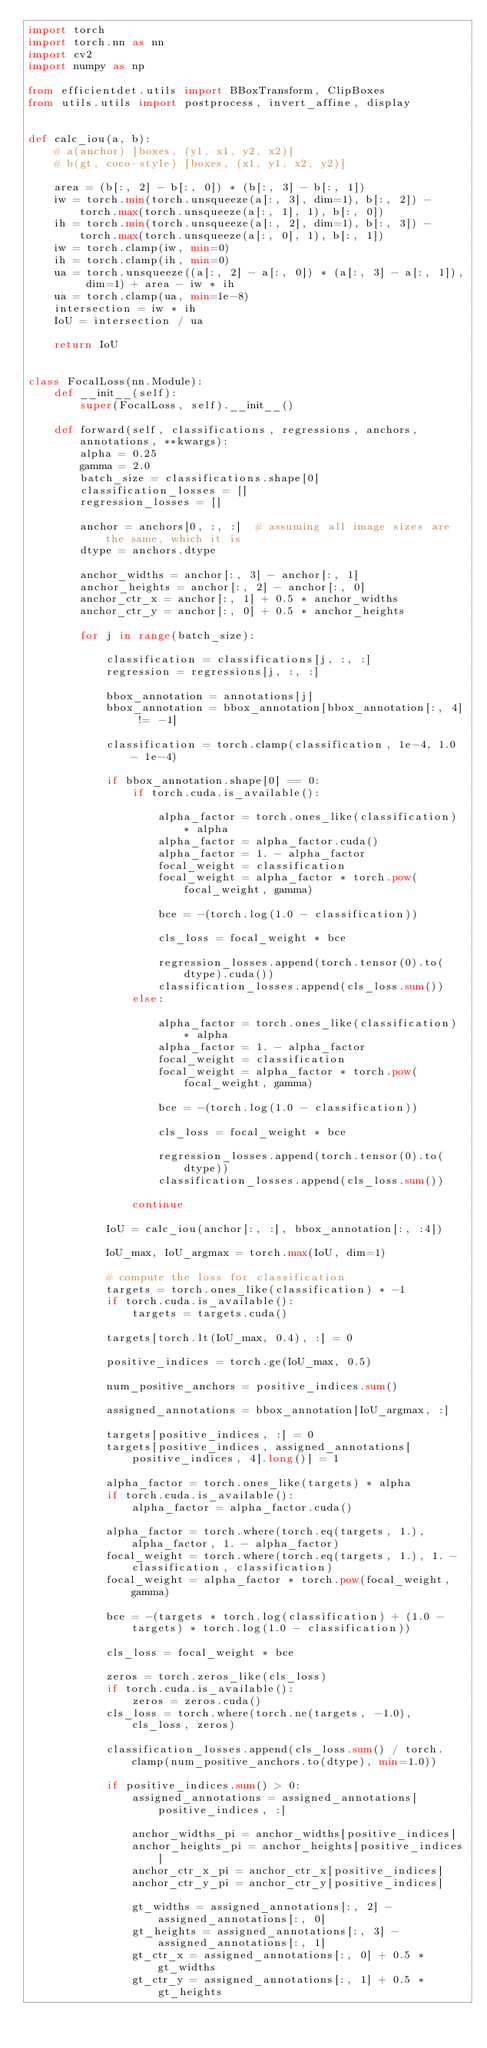<code> <loc_0><loc_0><loc_500><loc_500><_Python_>import torch
import torch.nn as nn
import cv2
import numpy as np

from efficientdet.utils import BBoxTransform, ClipBoxes
from utils.utils import postprocess, invert_affine, display


def calc_iou(a, b):
    # a(anchor) [boxes, (y1, x1, y2, x2)]
    # b(gt, coco-style) [boxes, (x1, y1, x2, y2)]

    area = (b[:, 2] - b[:, 0]) * (b[:, 3] - b[:, 1])
    iw = torch.min(torch.unsqueeze(a[:, 3], dim=1), b[:, 2]) - torch.max(torch.unsqueeze(a[:, 1], 1), b[:, 0])
    ih = torch.min(torch.unsqueeze(a[:, 2], dim=1), b[:, 3]) - torch.max(torch.unsqueeze(a[:, 0], 1), b[:, 1])
    iw = torch.clamp(iw, min=0)
    ih = torch.clamp(ih, min=0)
    ua = torch.unsqueeze((a[:, 2] - a[:, 0]) * (a[:, 3] - a[:, 1]), dim=1) + area - iw * ih
    ua = torch.clamp(ua, min=1e-8)
    intersection = iw * ih
    IoU = intersection / ua

    return IoU


class FocalLoss(nn.Module):
    def __init__(self):
        super(FocalLoss, self).__init__()

    def forward(self, classifications, regressions, anchors, annotations, **kwargs):
        alpha = 0.25
        gamma = 2.0
        batch_size = classifications.shape[0]
        classification_losses = []
        regression_losses = []

        anchor = anchors[0, :, :]  # assuming all image sizes are the same, which it is
        dtype = anchors.dtype

        anchor_widths = anchor[:, 3] - anchor[:, 1]
        anchor_heights = anchor[:, 2] - anchor[:, 0]
        anchor_ctr_x = anchor[:, 1] + 0.5 * anchor_widths
        anchor_ctr_y = anchor[:, 0] + 0.5 * anchor_heights

        for j in range(batch_size):

            classification = classifications[j, :, :]
            regression = regressions[j, :, :]

            bbox_annotation = annotations[j]
            bbox_annotation = bbox_annotation[bbox_annotation[:, 4] != -1]

            classification = torch.clamp(classification, 1e-4, 1.0 - 1e-4)
            
            if bbox_annotation.shape[0] == 0:
                if torch.cuda.is_available():
                    
                    alpha_factor = torch.ones_like(classification) * alpha
                    alpha_factor = alpha_factor.cuda()
                    alpha_factor = 1. - alpha_factor
                    focal_weight = classification
                    focal_weight = alpha_factor * torch.pow(focal_weight, gamma)
                    
                    bce = -(torch.log(1.0 - classification))
                    
                    cls_loss = focal_weight * bce
                    
                    regression_losses.append(torch.tensor(0).to(dtype).cuda())
                    classification_losses.append(cls_loss.sum())
                else:
                    
                    alpha_factor = torch.ones_like(classification) * alpha
                    alpha_factor = 1. - alpha_factor
                    focal_weight = classification
                    focal_weight = alpha_factor * torch.pow(focal_weight, gamma)
                    
                    bce = -(torch.log(1.0 - classification))
                    
                    cls_loss = focal_weight * bce
                    
                    regression_losses.append(torch.tensor(0).to(dtype))
                    classification_losses.append(cls_loss.sum())

                continue
                
            IoU = calc_iou(anchor[:, :], bbox_annotation[:, :4])

            IoU_max, IoU_argmax = torch.max(IoU, dim=1)

            # compute the loss for classification
            targets = torch.ones_like(classification) * -1
            if torch.cuda.is_available():
                targets = targets.cuda()

            targets[torch.lt(IoU_max, 0.4), :] = 0

            positive_indices = torch.ge(IoU_max, 0.5)

            num_positive_anchors = positive_indices.sum()

            assigned_annotations = bbox_annotation[IoU_argmax, :]

            targets[positive_indices, :] = 0
            targets[positive_indices, assigned_annotations[positive_indices, 4].long()] = 1

            alpha_factor = torch.ones_like(targets) * alpha
            if torch.cuda.is_available():
                alpha_factor = alpha_factor.cuda()

            alpha_factor = torch.where(torch.eq(targets, 1.), alpha_factor, 1. - alpha_factor)
            focal_weight = torch.where(torch.eq(targets, 1.), 1. - classification, classification)
            focal_weight = alpha_factor * torch.pow(focal_weight, gamma)

            bce = -(targets * torch.log(classification) + (1.0 - targets) * torch.log(1.0 - classification))

            cls_loss = focal_weight * bce

            zeros = torch.zeros_like(cls_loss)
            if torch.cuda.is_available():
                zeros = zeros.cuda()
            cls_loss = torch.where(torch.ne(targets, -1.0), cls_loss, zeros)

            classification_losses.append(cls_loss.sum() / torch.clamp(num_positive_anchors.to(dtype), min=1.0))

            if positive_indices.sum() > 0:
                assigned_annotations = assigned_annotations[positive_indices, :]

                anchor_widths_pi = anchor_widths[positive_indices]
                anchor_heights_pi = anchor_heights[positive_indices]
                anchor_ctr_x_pi = anchor_ctr_x[positive_indices]
                anchor_ctr_y_pi = anchor_ctr_y[positive_indices]

                gt_widths = assigned_annotations[:, 2] - assigned_annotations[:, 0]
                gt_heights = assigned_annotations[:, 3] - assigned_annotations[:, 1]
                gt_ctr_x = assigned_annotations[:, 0] + 0.5 * gt_widths
                gt_ctr_y = assigned_annotations[:, 1] + 0.5 * gt_heights
</code> 